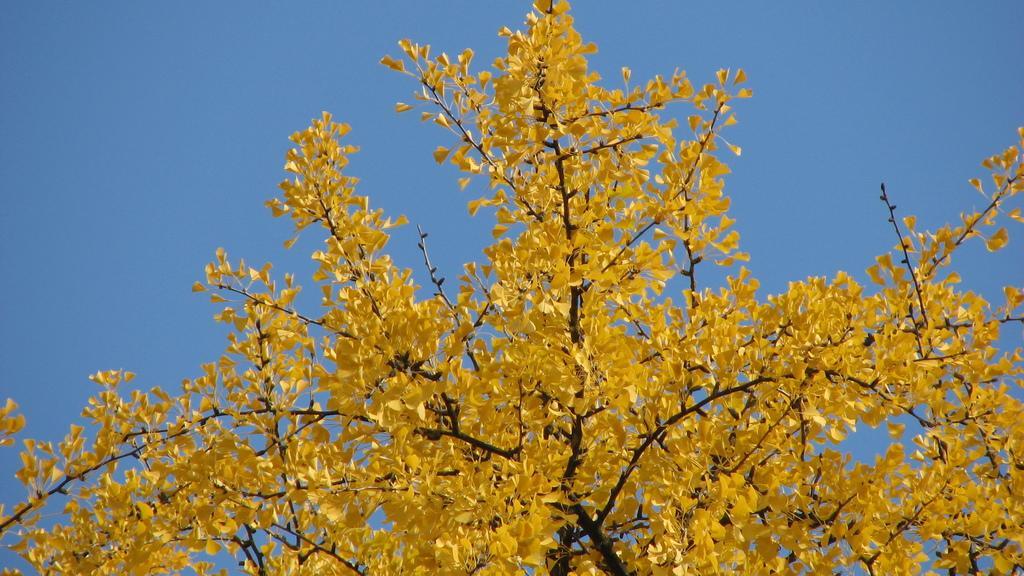Describe this image in one or two sentences. n this image i can see a tree, where the leaves are in yellow color, at the background i can see a sky in blue color. 